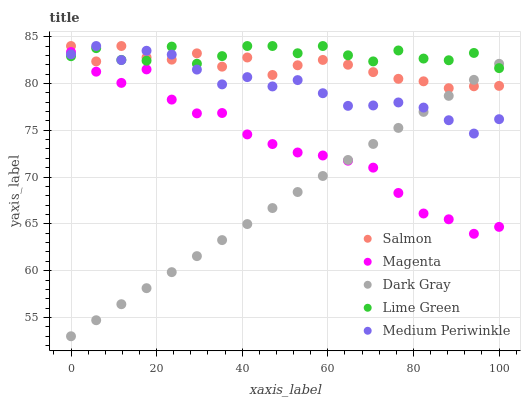Does Dark Gray have the minimum area under the curve?
Answer yes or no. Yes. Does Lime Green have the maximum area under the curve?
Answer yes or no. Yes. Does Magenta have the minimum area under the curve?
Answer yes or no. No. Does Magenta have the maximum area under the curve?
Answer yes or no. No. Is Dark Gray the smoothest?
Answer yes or no. Yes. Is Lime Green the roughest?
Answer yes or no. Yes. Is Magenta the smoothest?
Answer yes or no. No. Is Magenta the roughest?
Answer yes or no. No. Does Dark Gray have the lowest value?
Answer yes or no. Yes. Does Magenta have the lowest value?
Answer yes or no. No. Does Medium Periwinkle have the highest value?
Answer yes or no. Yes. Does Magenta have the highest value?
Answer yes or no. No. Is Magenta less than Salmon?
Answer yes or no. Yes. Is Salmon greater than Magenta?
Answer yes or no. Yes. Does Dark Gray intersect Medium Periwinkle?
Answer yes or no. Yes. Is Dark Gray less than Medium Periwinkle?
Answer yes or no. No. Is Dark Gray greater than Medium Periwinkle?
Answer yes or no. No. Does Magenta intersect Salmon?
Answer yes or no. No. 